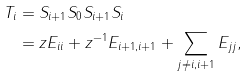Convert formula to latex. <formula><loc_0><loc_0><loc_500><loc_500>T _ { i } & = S _ { i + 1 } S _ { 0 } S _ { i + 1 } S _ { i } \\ & = z E _ { i i } + z ^ { - 1 } E _ { i + 1 , i + 1 } + \sum _ { j \neq i , i + 1 } E _ { j j } ,</formula> 